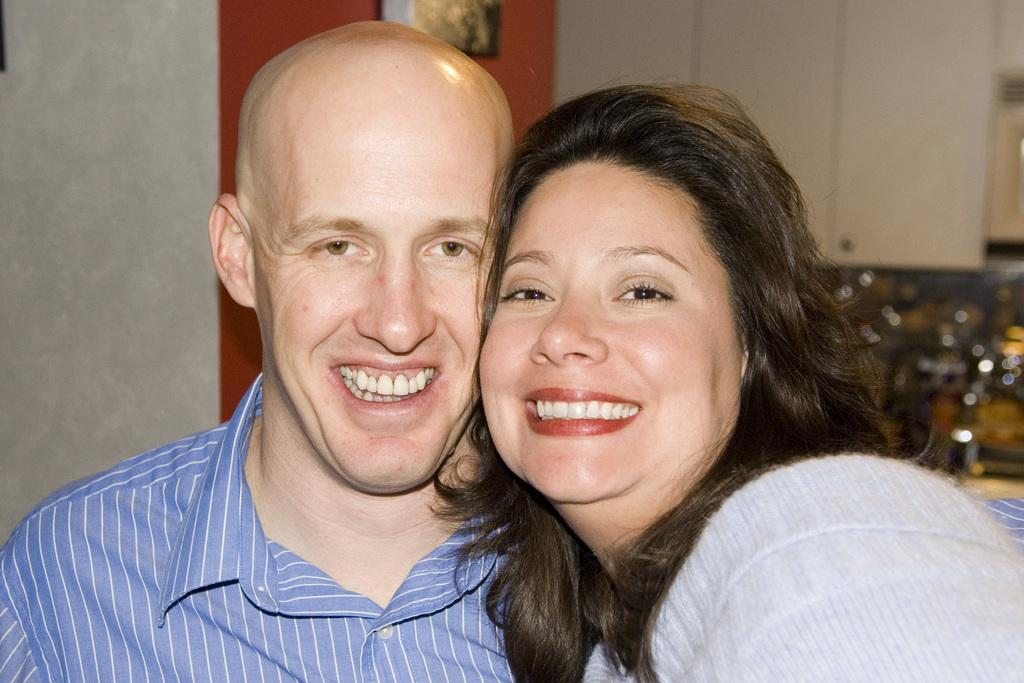Who is present in the image? There is a man and a woman in the image. What are the man and woman doing in the image? The man and woman are standing together and smiling. Where does the scene take place? The scene takes place in a room. What type of cream can be seen on the floor in the image? There is no cream visible on the floor in the image. What territory is being claimed by the man and woman in the image? The image does not depict any territorial claims or disputes; it simply shows a man and woman standing together and smiling. 